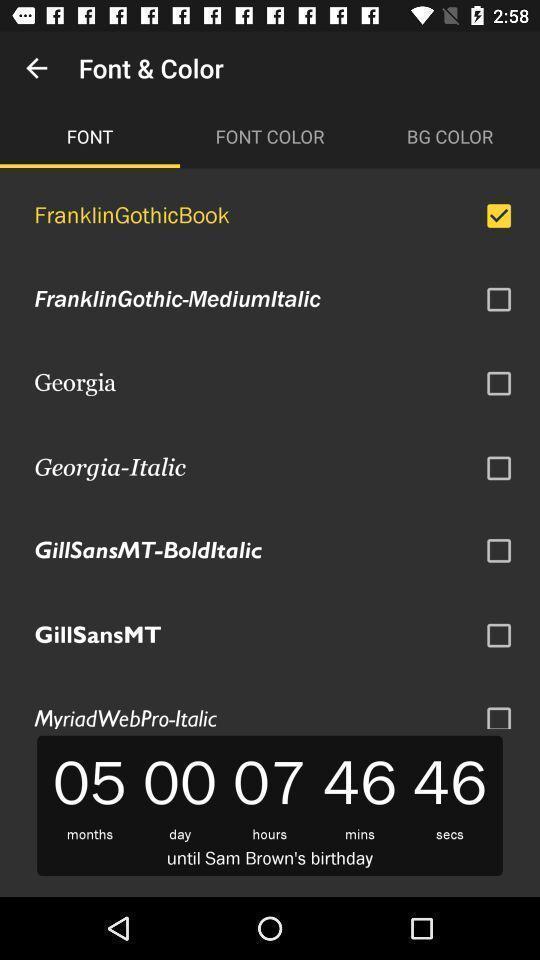Describe the key features of this screenshot. Screen showing list of font to select. 